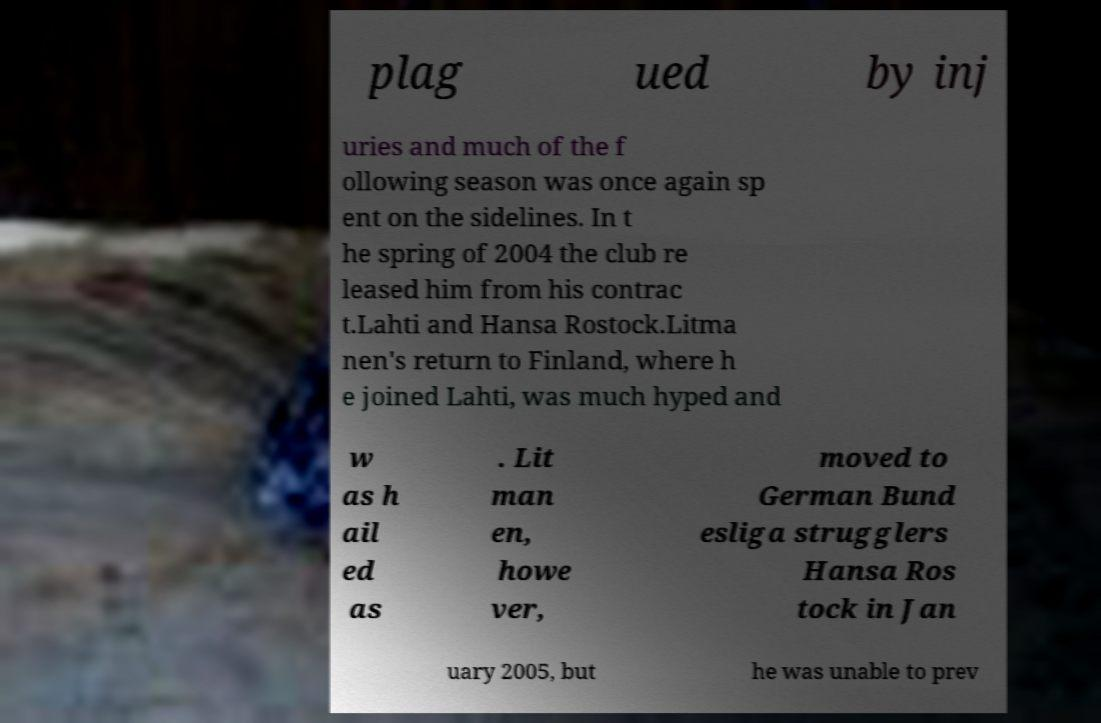For documentation purposes, I need the text within this image transcribed. Could you provide that? plag ued by inj uries and much of the f ollowing season was once again sp ent on the sidelines. In t he spring of 2004 the club re leased him from his contrac t.Lahti and Hansa Rostock.Litma nen's return to Finland, where h e joined Lahti, was much hyped and w as h ail ed as . Lit man en, howe ver, moved to German Bund esliga strugglers Hansa Ros tock in Jan uary 2005, but he was unable to prev 